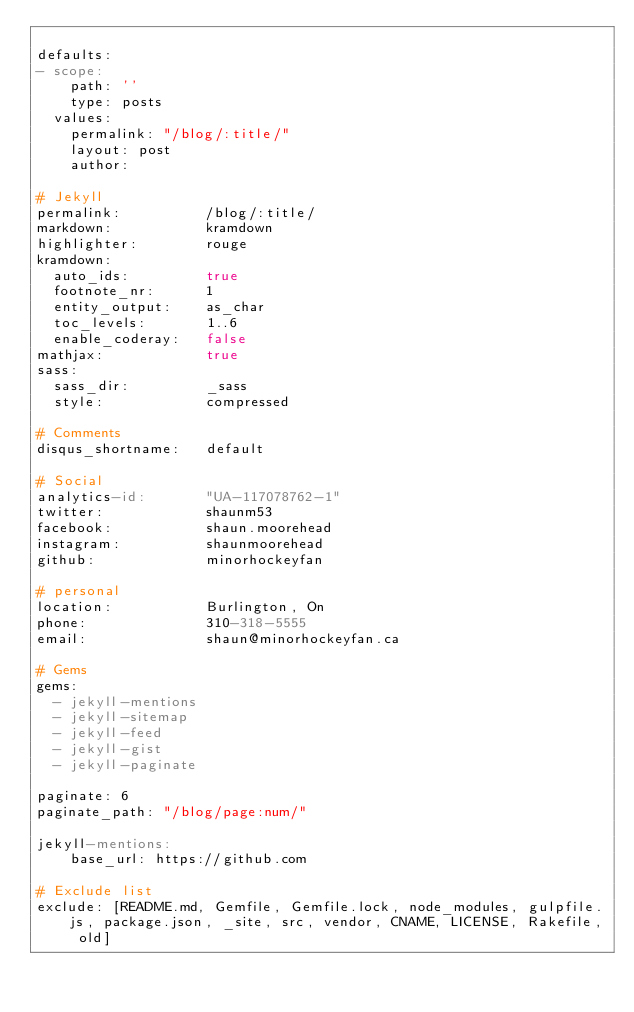Convert code to text. <code><loc_0><loc_0><loc_500><loc_500><_YAML_>
defaults:
- scope:
    path: ''
    type: posts
  values:
    permalink: "/blog/:title/"
    layout: post
    author:

# Jekyll
permalink:          /blog/:title/
markdown:           kramdown
highlighter:        rouge
kramdown:
  auto_ids:         true
  footnote_nr:      1
  entity_output:    as_char
  toc_levels:       1..6
  enable_coderay:   false
mathjax:            true
sass:
  sass_dir:         _sass
  style:            compressed

# Comments
disqus_shortname:   default

# Social
analytics-id:       "UA-117078762-1"
twitter:            shaunm53
facebook:           shaun.moorehead
instagram:          shaunmoorehead
github:             minorhockeyfan

# personal
location:           Burlington, On
phone:              310-318-5555
email:              shaun@minorhockeyfan.ca

# Gems
gems:
  - jekyll-mentions
  - jekyll-sitemap
  - jekyll-feed
  - jekyll-gist
  - jekyll-paginate

paginate: 6
paginate_path: "/blog/page:num/"

jekyll-mentions:
    base_url: https://github.com

# Exclude list
exclude: [README.md, Gemfile, Gemfile.lock, node_modules, gulpfile.js, package.json, _site, src, vendor, CNAME, LICENSE, Rakefile, old]
</code> 